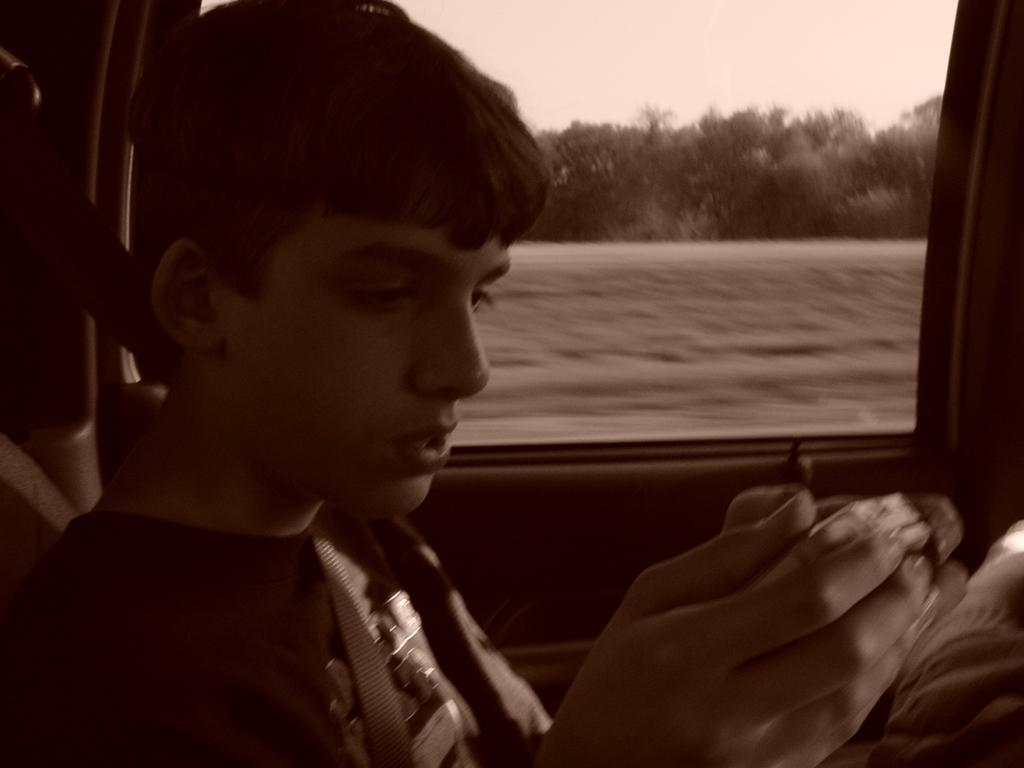What is the boy doing in the vehicle? The boy is sitting inside the vehicle. What is the boy holding in the image? The boy is holding an object. What can be seen behind the mirror in the image? There are trees visible behind the mirror. What type of vegetation is present in the image? There is grass in the image. What is visible at the top of the image? The sky is visible at the top of the image. What causes the sleet to fall in the image? There is no mention of sleet in the image, so we cannot determine the cause of its presence. 